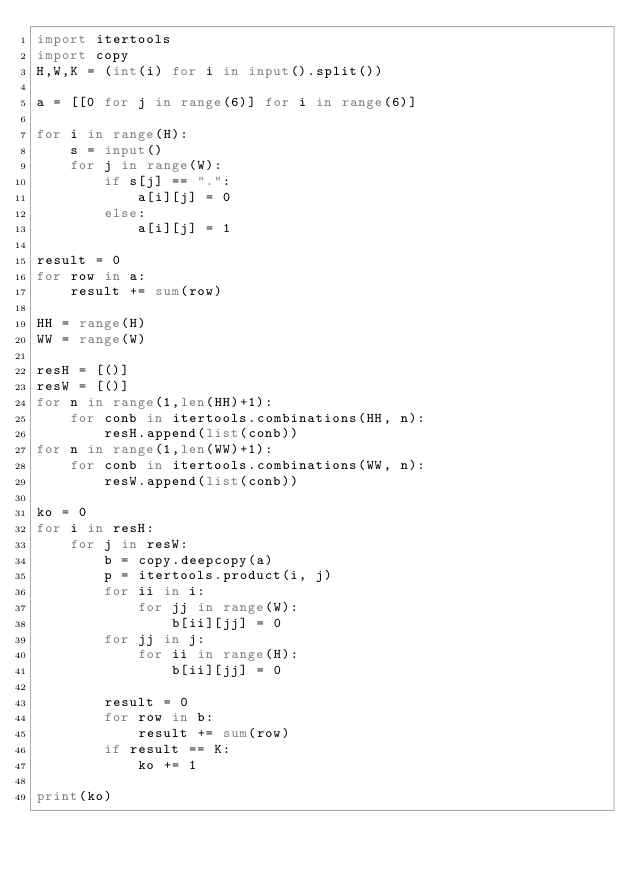Convert code to text. <code><loc_0><loc_0><loc_500><loc_500><_Python_>import itertools
import copy
H,W,K = (int(i) for i in input().split())

a = [[0 for j in range(6)] for i in range(6)]

for i in range(H):
    s = input()
    for j in range(W):
        if s[j] == ".":
            a[i][j] = 0
        else:
            a[i][j] = 1

result = 0
for row in a:
    result += sum(row)

HH = range(H)
WW = range(W)

resH = [()]
resW = [()]
for n in range(1,len(HH)+1):
    for conb in itertools.combinations(HH, n):
        resH.append(list(conb)) 
for n in range(1,len(WW)+1):
    for conb in itertools.combinations(WW, n):
        resW.append(list(conb)) 

ko = 0
for i in resH:
    for j in resW:
        b = copy.deepcopy(a)
        p = itertools.product(i, j)
        for ii in i:
            for jj in range(W):
                b[ii][jj] = 0
        for jj in j:
            for ii in range(H):
                b[ii][jj] = 0

        result = 0
        for row in b:
            result += sum(row)
        if result == K:
            ko += 1

print(ko)


</code> 